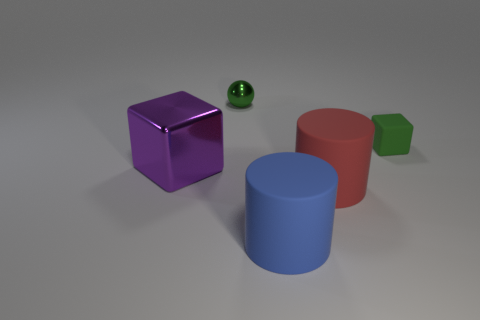Can you tell me what materials the objects in the image might be made of? Certainly, the objects appear to be computer-generated and have different materials. The purple and green blocks have a reflective material that suggests a metallic finish. The blue and red cylinders seem to have a matte, possibly rubbery surface. 